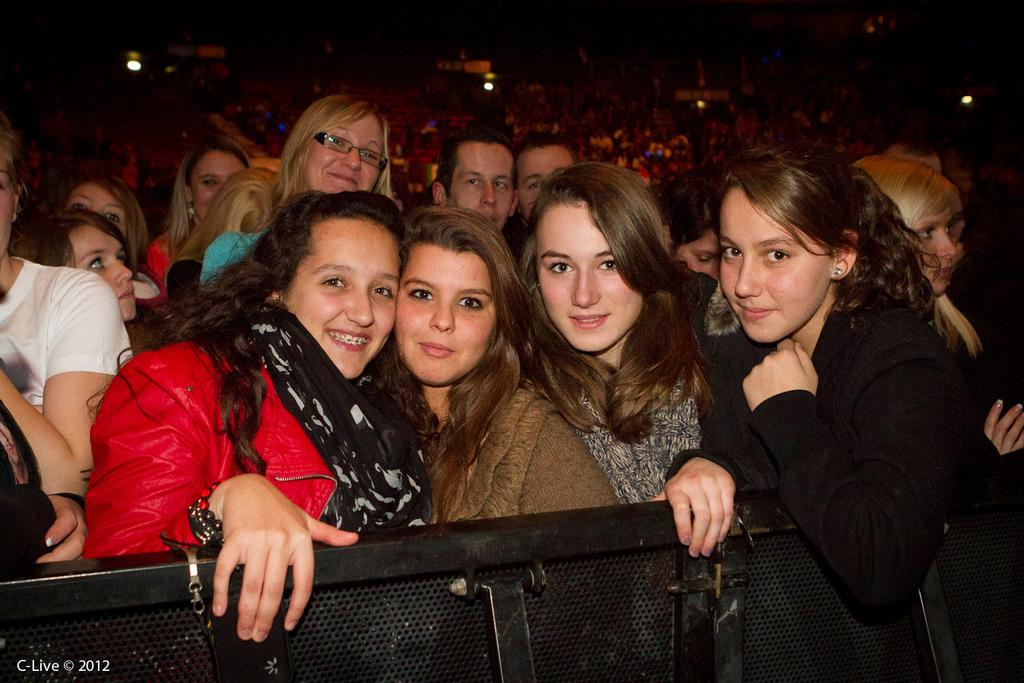What can be seen in the image? There is a group of women in the image. What are the women doing in the image? The women are standing and smiling. What are the women wearing in the image? The women are wearing sweaters. What else can be seen in the image? There are men in the background of the image, and there are lights visible. What type of star can be seen on the women's sweaters in the image? There is no star visible on the women's sweaters in the image. Can you describe the tramp that is sitting next to the women in the image? There is no tramp present in the image; it only features a group of women and men in the background. 